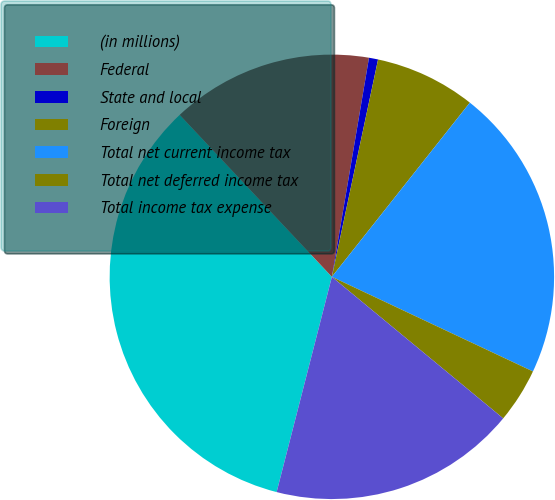Convert chart. <chart><loc_0><loc_0><loc_500><loc_500><pie_chart><fcel>(in millions)<fcel>Federal<fcel>State and local<fcel>Foreign<fcel>Total net current income tax<fcel>Total net deferred income tax<fcel>Total income tax expense<nl><fcel>34.0%<fcel>14.68%<fcel>0.66%<fcel>7.33%<fcel>21.34%<fcel>3.99%<fcel>18.01%<nl></chart> 